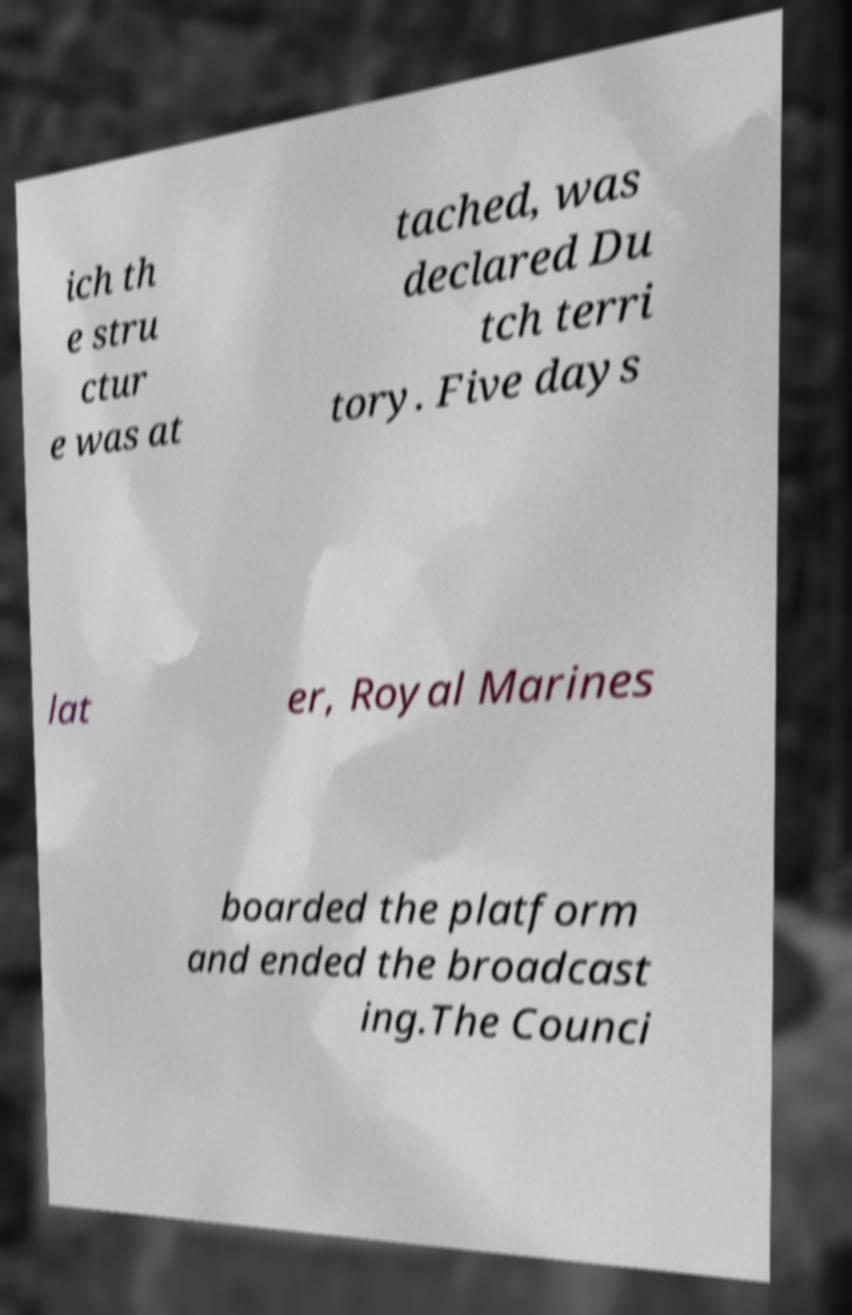Please identify and transcribe the text found in this image. ich th e stru ctur e was at tached, was declared Du tch terri tory. Five days lat er, Royal Marines boarded the platform and ended the broadcast ing.The Counci 